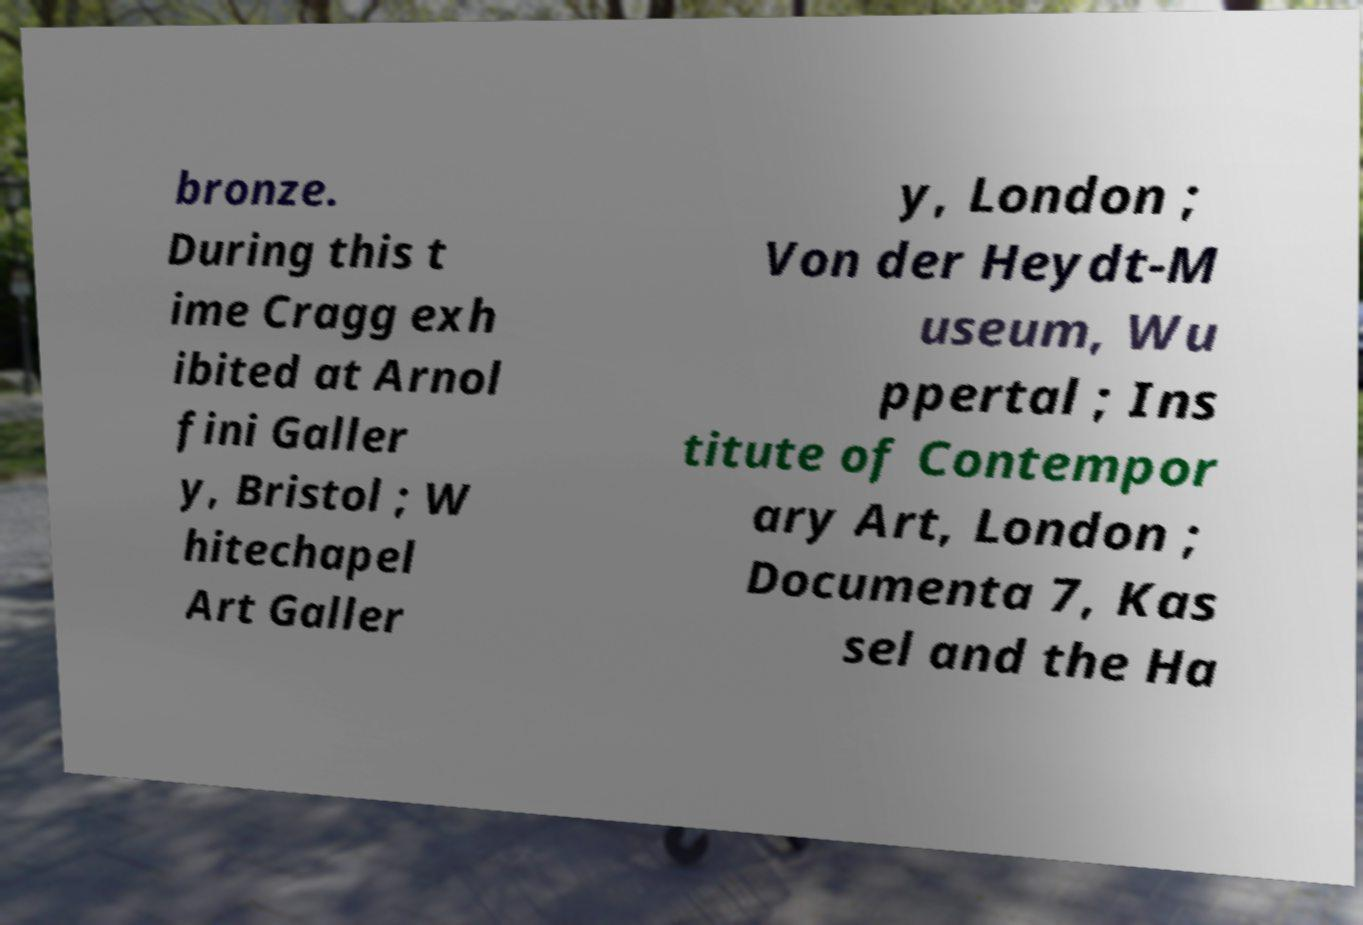Please read and relay the text visible in this image. What does it say? bronze. During this t ime Cragg exh ibited at Arnol fini Galler y, Bristol ; W hitechapel Art Galler y, London ; Von der Heydt-M useum, Wu ppertal ; Ins titute of Contempor ary Art, London ; Documenta 7, Kas sel and the Ha 